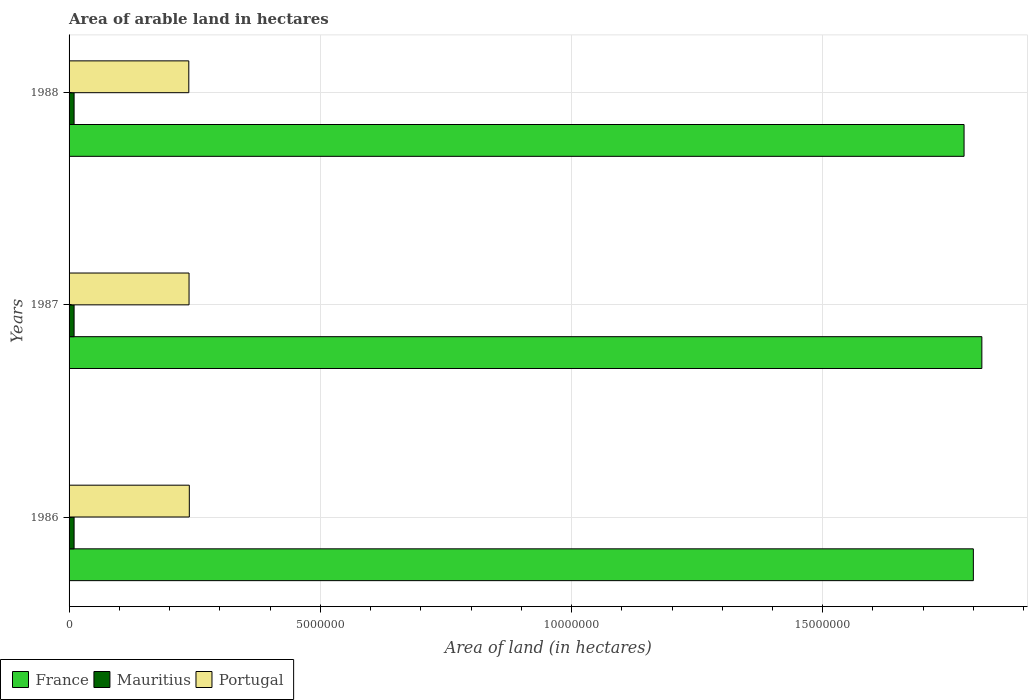How many groups of bars are there?
Provide a succinct answer. 3. Are the number of bars on each tick of the Y-axis equal?
Your answer should be very brief. Yes. How many bars are there on the 3rd tick from the bottom?
Provide a succinct answer. 3. What is the total arable land in Mauritius in 1987?
Give a very brief answer. 1.00e+05. Across all years, what is the maximum total arable land in Mauritius?
Your answer should be compact. 1.00e+05. Across all years, what is the minimum total arable land in Mauritius?
Give a very brief answer. 1.00e+05. In which year was the total arable land in France maximum?
Your answer should be very brief. 1987. What is the total total arable land in Portugal in the graph?
Provide a short and direct response. 7.16e+06. What is the difference between the total arable land in France in 1987 and that in 1988?
Give a very brief answer. 3.54e+05. What is the difference between the total arable land in Mauritius in 1987 and the total arable land in France in 1986?
Give a very brief answer. -1.79e+07. What is the average total arable land in France per year?
Offer a very short reply. 1.80e+07. In the year 1988, what is the difference between the total arable land in France and total arable land in Portugal?
Your answer should be compact. 1.54e+07. What is the ratio of the total arable land in Portugal in 1987 to that in 1988?
Give a very brief answer. 1. Is the total arable land in France in 1986 less than that in 1988?
Give a very brief answer. No. Is the difference between the total arable land in France in 1986 and 1987 greater than the difference between the total arable land in Portugal in 1986 and 1987?
Keep it short and to the point. No. What is the difference between the highest and the second highest total arable land in Portugal?
Offer a terse response. 5000. What is the difference between the highest and the lowest total arable land in France?
Offer a very short reply. 3.54e+05. In how many years, is the total arable land in Portugal greater than the average total arable land in Portugal taken over all years?
Your answer should be compact. 1. Is the sum of the total arable land in Portugal in 1986 and 1988 greater than the maximum total arable land in France across all years?
Keep it short and to the point. No. What does the 1st bar from the top in 1988 represents?
Your response must be concise. Portugal. How many years are there in the graph?
Keep it short and to the point. 3. How are the legend labels stacked?
Ensure brevity in your answer.  Horizontal. What is the title of the graph?
Offer a terse response. Area of arable land in hectares. Does "Papua New Guinea" appear as one of the legend labels in the graph?
Ensure brevity in your answer.  No. What is the label or title of the X-axis?
Keep it short and to the point. Area of land (in hectares). What is the label or title of the Y-axis?
Your answer should be compact. Years. What is the Area of land (in hectares) in France in 1986?
Provide a succinct answer. 1.80e+07. What is the Area of land (in hectares) of Portugal in 1986?
Ensure brevity in your answer.  2.39e+06. What is the Area of land (in hectares) of France in 1987?
Your response must be concise. 1.82e+07. What is the Area of land (in hectares) of Portugal in 1987?
Provide a succinct answer. 2.39e+06. What is the Area of land (in hectares) in France in 1988?
Keep it short and to the point. 1.78e+07. What is the Area of land (in hectares) of Mauritius in 1988?
Offer a terse response. 1.00e+05. What is the Area of land (in hectares) of Portugal in 1988?
Your answer should be compact. 2.38e+06. Across all years, what is the maximum Area of land (in hectares) of France?
Offer a terse response. 1.82e+07. Across all years, what is the maximum Area of land (in hectares) in Portugal?
Provide a succinct answer. 2.39e+06. Across all years, what is the minimum Area of land (in hectares) in France?
Give a very brief answer. 1.78e+07. Across all years, what is the minimum Area of land (in hectares) in Portugal?
Your response must be concise. 2.38e+06. What is the total Area of land (in hectares) in France in the graph?
Your answer should be compact. 5.40e+07. What is the total Area of land (in hectares) in Mauritius in the graph?
Ensure brevity in your answer.  3.00e+05. What is the total Area of land (in hectares) in Portugal in the graph?
Ensure brevity in your answer.  7.16e+06. What is the difference between the Area of land (in hectares) in France in 1986 and that in 1987?
Make the answer very short. -1.69e+05. What is the difference between the Area of land (in hectares) in France in 1986 and that in 1988?
Your answer should be very brief. 1.85e+05. What is the difference between the Area of land (in hectares) of Portugal in 1986 and that in 1988?
Offer a terse response. 10000. What is the difference between the Area of land (in hectares) in France in 1987 and that in 1988?
Offer a very short reply. 3.54e+05. What is the difference between the Area of land (in hectares) in Mauritius in 1987 and that in 1988?
Your answer should be very brief. 0. What is the difference between the Area of land (in hectares) of France in 1986 and the Area of land (in hectares) of Mauritius in 1987?
Provide a succinct answer. 1.79e+07. What is the difference between the Area of land (in hectares) in France in 1986 and the Area of land (in hectares) in Portugal in 1987?
Ensure brevity in your answer.  1.56e+07. What is the difference between the Area of land (in hectares) in Mauritius in 1986 and the Area of land (in hectares) in Portugal in 1987?
Keep it short and to the point. -2.29e+06. What is the difference between the Area of land (in hectares) of France in 1986 and the Area of land (in hectares) of Mauritius in 1988?
Offer a very short reply. 1.79e+07. What is the difference between the Area of land (in hectares) in France in 1986 and the Area of land (in hectares) in Portugal in 1988?
Make the answer very short. 1.56e+07. What is the difference between the Area of land (in hectares) of Mauritius in 1986 and the Area of land (in hectares) of Portugal in 1988?
Provide a succinct answer. -2.28e+06. What is the difference between the Area of land (in hectares) in France in 1987 and the Area of land (in hectares) in Mauritius in 1988?
Your answer should be compact. 1.81e+07. What is the difference between the Area of land (in hectares) of France in 1987 and the Area of land (in hectares) of Portugal in 1988?
Offer a terse response. 1.58e+07. What is the difference between the Area of land (in hectares) of Mauritius in 1987 and the Area of land (in hectares) of Portugal in 1988?
Provide a short and direct response. -2.28e+06. What is the average Area of land (in hectares) in France per year?
Your answer should be compact. 1.80e+07. What is the average Area of land (in hectares) in Portugal per year?
Ensure brevity in your answer.  2.39e+06. In the year 1986, what is the difference between the Area of land (in hectares) in France and Area of land (in hectares) in Mauritius?
Your response must be concise. 1.79e+07. In the year 1986, what is the difference between the Area of land (in hectares) of France and Area of land (in hectares) of Portugal?
Offer a terse response. 1.56e+07. In the year 1986, what is the difference between the Area of land (in hectares) of Mauritius and Area of land (in hectares) of Portugal?
Offer a terse response. -2.29e+06. In the year 1987, what is the difference between the Area of land (in hectares) of France and Area of land (in hectares) of Mauritius?
Ensure brevity in your answer.  1.81e+07. In the year 1987, what is the difference between the Area of land (in hectares) in France and Area of land (in hectares) in Portugal?
Make the answer very short. 1.58e+07. In the year 1987, what is the difference between the Area of land (in hectares) of Mauritius and Area of land (in hectares) of Portugal?
Your answer should be very brief. -2.29e+06. In the year 1988, what is the difference between the Area of land (in hectares) in France and Area of land (in hectares) in Mauritius?
Offer a terse response. 1.77e+07. In the year 1988, what is the difference between the Area of land (in hectares) in France and Area of land (in hectares) in Portugal?
Offer a very short reply. 1.54e+07. In the year 1988, what is the difference between the Area of land (in hectares) of Mauritius and Area of land (in hectares) of Portugal?
Make the answer very short. -2.28e+06. What is the ratio of the Area of land (in hectares) of Mauritius in 1986 to that in 1987?
Ensure brevity in your answer.  1. What is the ratio of the Area of land (in hectares) in France in 1986 to that in 1988?
Keep it short and to the point. 1.01. What is the ratio of the Area of land (in hectares) of France in 1987 to that in 1988?
Offer a terse response. 1.02. What is the ratio of the Area of land (in hectares) of Mauritius in 1987 to that in 1988?
Your response must be concise. 1. What is the ratio of the Area of land (in hectares) in Portugal in 1987 to that in 1988?
Provide a short and direct response. 1. What is the difference between the highest and the second highest Area of land (in hectares) of France?
Offer a terse response. 1.69e+05. What is the difference between the highest and the lowest Area of land (in hectares) in France?
Provide a short and direct response. 3.54e+05. 